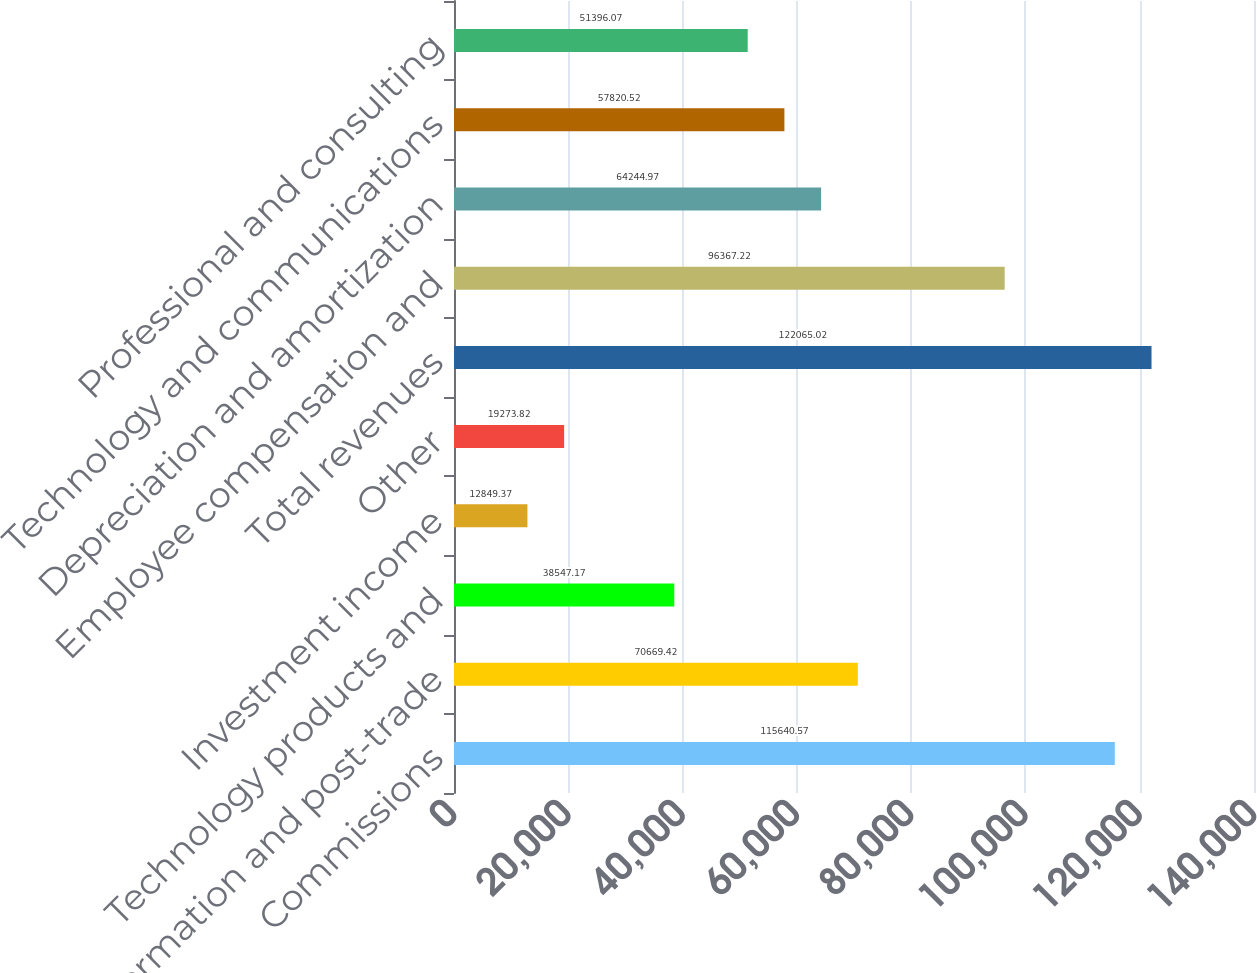<chart> <loc_0><loc_0><loc_500><loc_500><bar_chart><fcel>Commissions<fcel>Information and post-trade<fcel>Technology products and<fcel>Investment income<fcel>Other<fcel>Total revenues<fcel>Employee compensation and<fcel>Depreciation and amortization<fcel>Technology and communications<fcel>Professional and consulting<nl><fcel>115641<fcel>70669.4<fcel>38547.2<fcel>12849.4<fcel>19273.8<fcel>122065<fcel>96367.2<fcel>64245<fcel>57820.5<fcel>51396.1<nl></chart> 